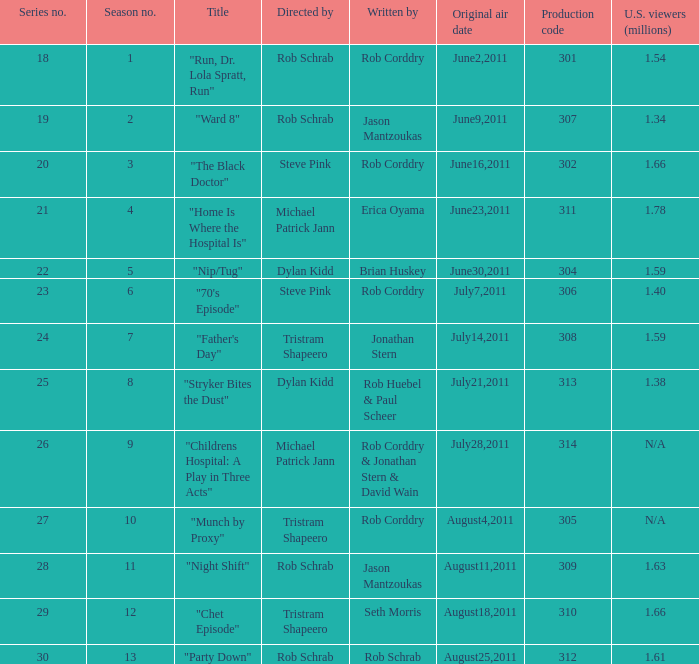Who was in charge of directing the episode titled "home is where the hospital is"? Michael Patrick Jann. 